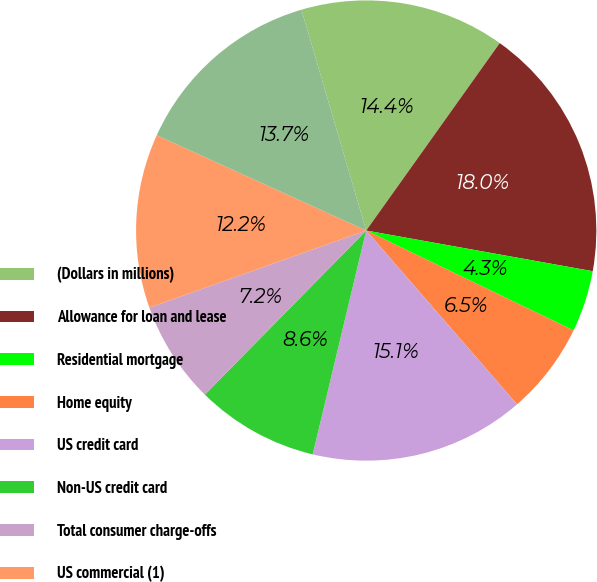Convert chart to OTSL. <chart><loc_0><loc_0><loc_500><loc_500><pie_chart><fcel>(Dollars in millions)<fcel>Allowance for loan and lease<fcel>Residential mortgage<fcel>Home equity<fcel>US credit card<fcel>Non-US credit card<fcel>Total consumer charge-offs<fcel>US commercial (1)<fcel>Total commercial charge-offs<nl><fcel>14.39%<fcel>17.98%<fcel>4.32%<fcel>6.48%<fcel>15.11%<fcel>8.63%<fcel>7.2%<fcel>12.23%<fcel>13.67%<nl></chart> 